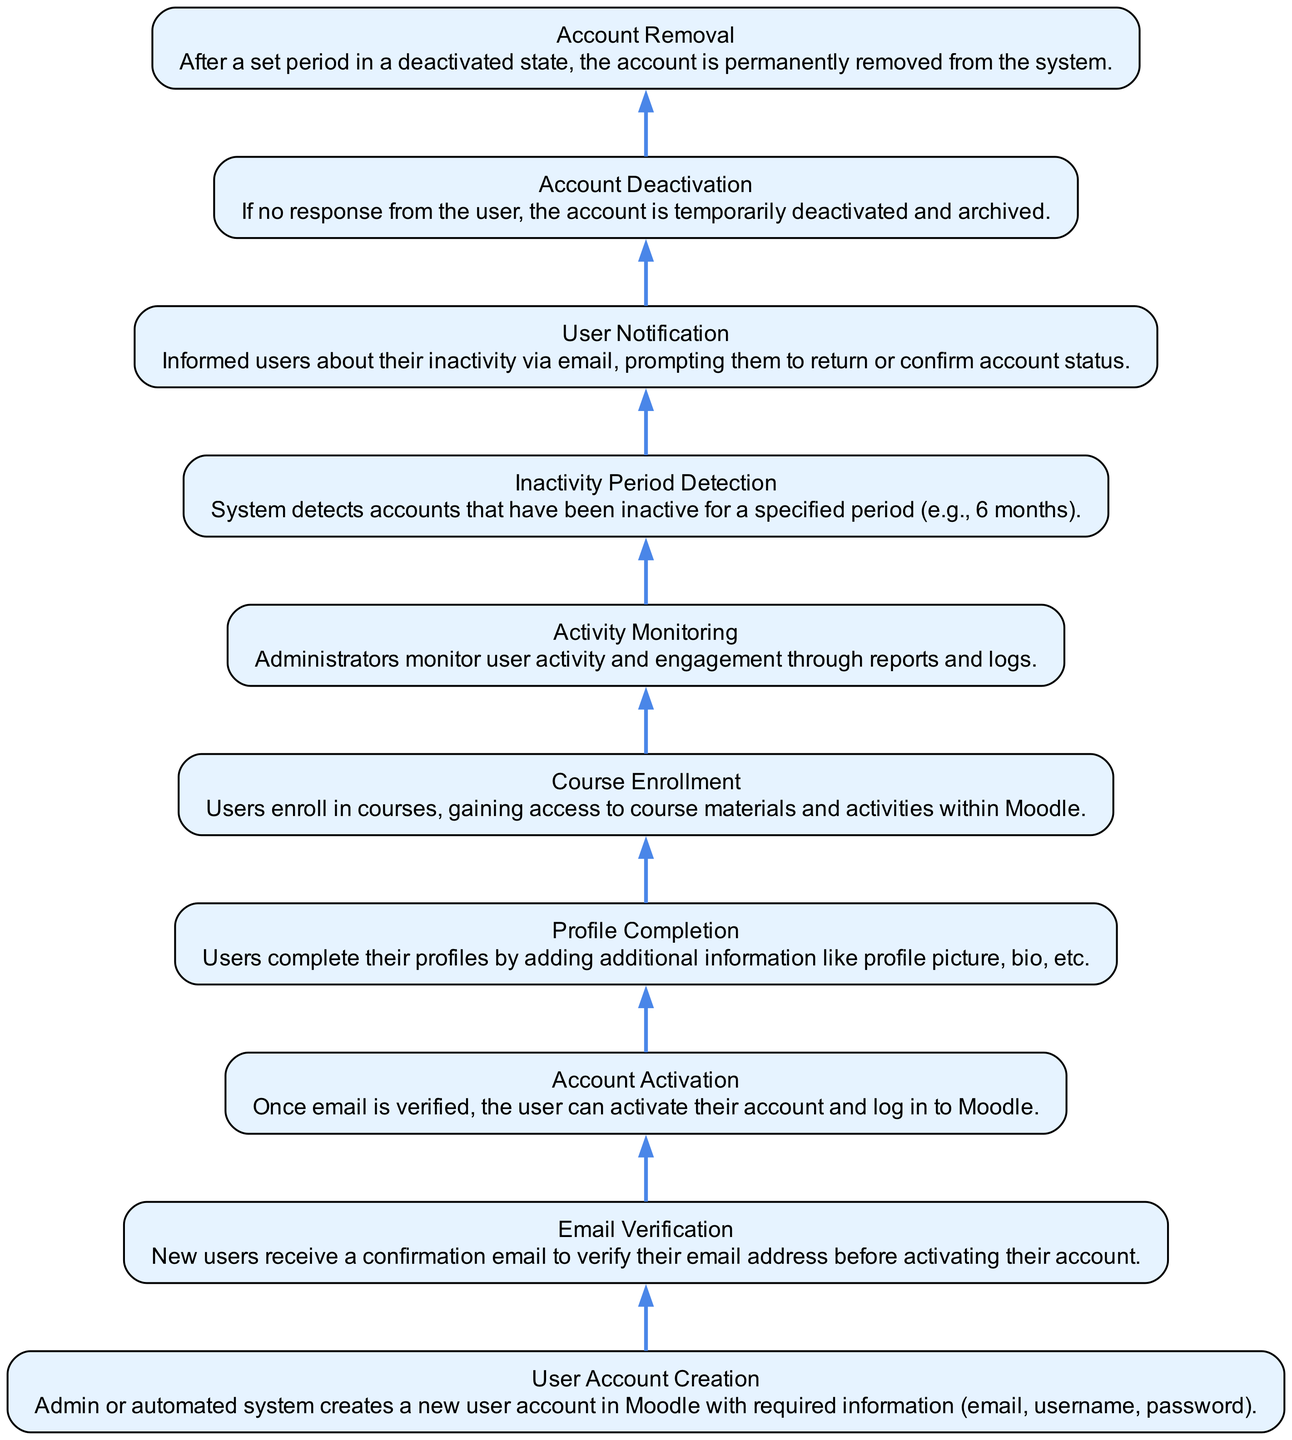What is the first step in the user account management process? According to the diagram, the first node is "User Account Creation," indicating that the user management process begins with creating a new user account.
Answer: User Account Creation How many steps are there in the process from creation to removal? The diagram consists of ten distinct nodes, each representing a specific step in the user account management process, from creation to removal of accounts.
Answer: Ten What is the purpose of the "User Notification" step? The "User Notification" step is designed to inform users about their inactivity via email, prompting them to return or confirm their account status, as indicated in the description.
Answer: Inform users Which step follows "Profile Completion"? According to the flow of the diagram, the step that follows "Profile Completion" is "Course Enrollment," where users begin enrolling in courses after completing their profiles.
Answer: Course Enrollment What happens if a user does not respond to the inactivity notification? If there is no response from the user regarding the inactivity notification, the next step is "Account Deactivation," where the account is temporarily deactivated and archived, as shown in the hierarchy.
Answer: Account Deactivation How many steps are involved after a user completes their profile? After completing their profile, there are three steps involved leading to account removal: "Course Enrollment," "Activity Monitoring," and subsequently handling inactivity through detection, notification, deactivation, and removal.
Answer: Three What is the final step in the user account management process? The final node in the diagram is "Account Removal," indicating that after a set period in a deactivated state, accounts are permanently removed from the system.
Answer: Account Removal What does the step "Inactivity Period Detection" indicate about user accounts? "Inactivity Period Detection" signifies that the system is programmed to detect accounts that have not been active for a specified duration, for instance, six months, as outlined in the description of that step.
Answer: Inactive accounts What action follows the step "Account Activation"? According to the workflow, once a user activates their account after email verification, the following action is "Profile Completion," where they provide additional information.
Answer: Profile Completion How does the diagram illustrate the process flow? The diagram illustrates the process flow by using a bottom-up approach, starting from "User Account Creation" at the bottom and leading to "Account Removal" at the top, depicting a sequential process.
Answer: Sequential process 